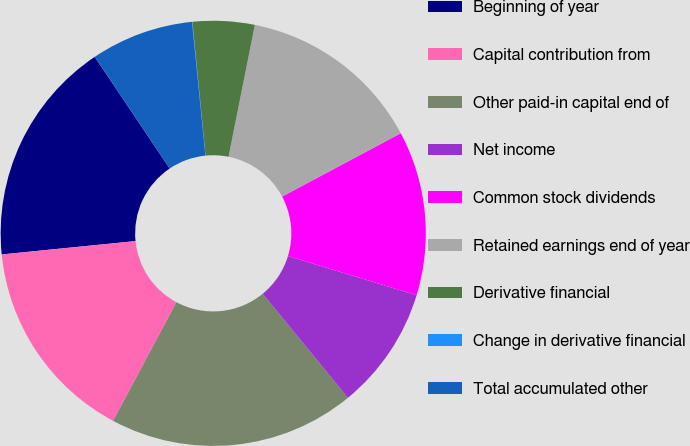<chart> <loc_0><loc_0><loc_500><loc_500><pie_chart><fcel>Beginning of year<fcel>Capital contribution from<fcel>Other paid-in capital end of<fcel>Net income<fcel>Common stock dividends<fcel>Retained earnings end of year<fcel>Derivative financial<fcel>Change in derivative financial<fcel>Total accumulated other<nl><fcel>17.17%<fcel>15.61%<fcel>18.73%<fcel>9.38%<fcel>12.5%<fcel>14.06%<fcel>4.7%<fcel>0.03%<fcel>7.82%<nl></chart> 